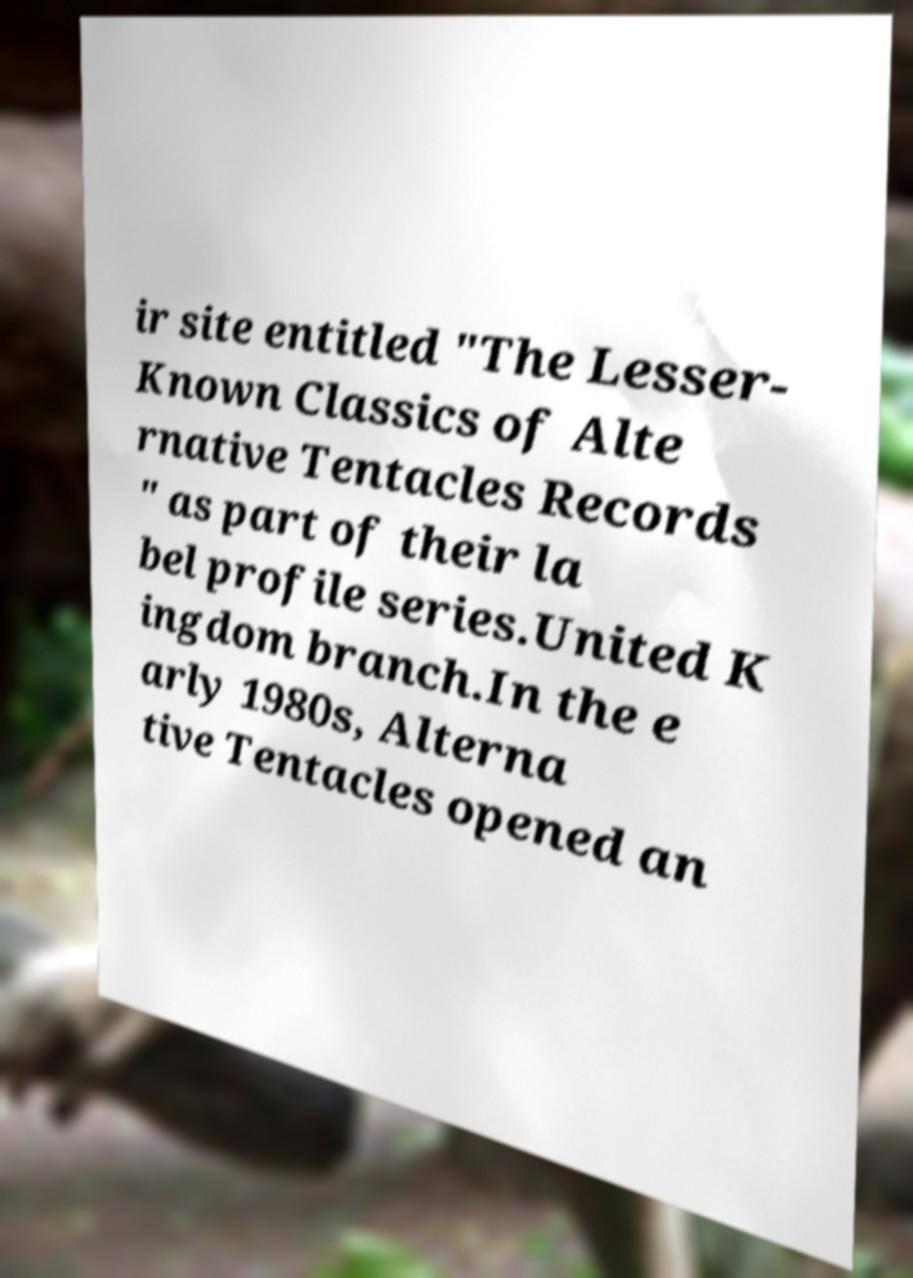What messages or text are displayed in this image? I need them in a readable, typed format. ir site entitled "The Lesser- Known Classics of Alte rnative Tentacles Records " as part of their la bel profile series.United K ingdom branch.In the e arly 1980s, Alterna tive Tentacles opened an 